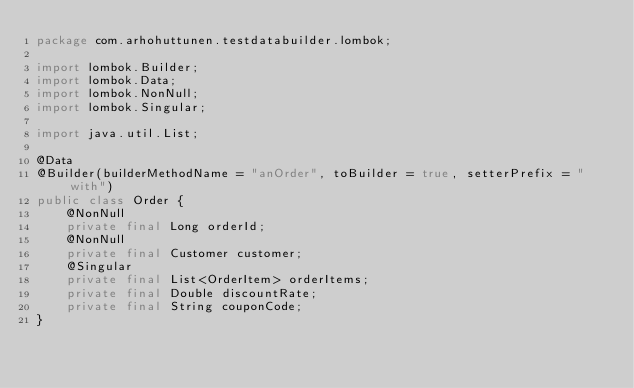Convert code to text. <code><loc_0><loc_0><loc_500><loc_500><_Java_>package com.arhohuttunen.testdatabuilder.lombok;

import lombok.Builder;
import lombok.Data;
import lombok.NonNull;
import lombok.Singular;

import java.util.List;

@Data
@Builder(builderMethodName = "anOrder", toBuilder = true, setterPrefix = "with")
public class Order {
    @NonNull
    private final Long orderId;
    @NonNull
    private final Customer customer;
    @Singular
    private final List<OrderItem> orderItems;
    private final Double discountRate;
    private final String couponCode;
}
</code> 